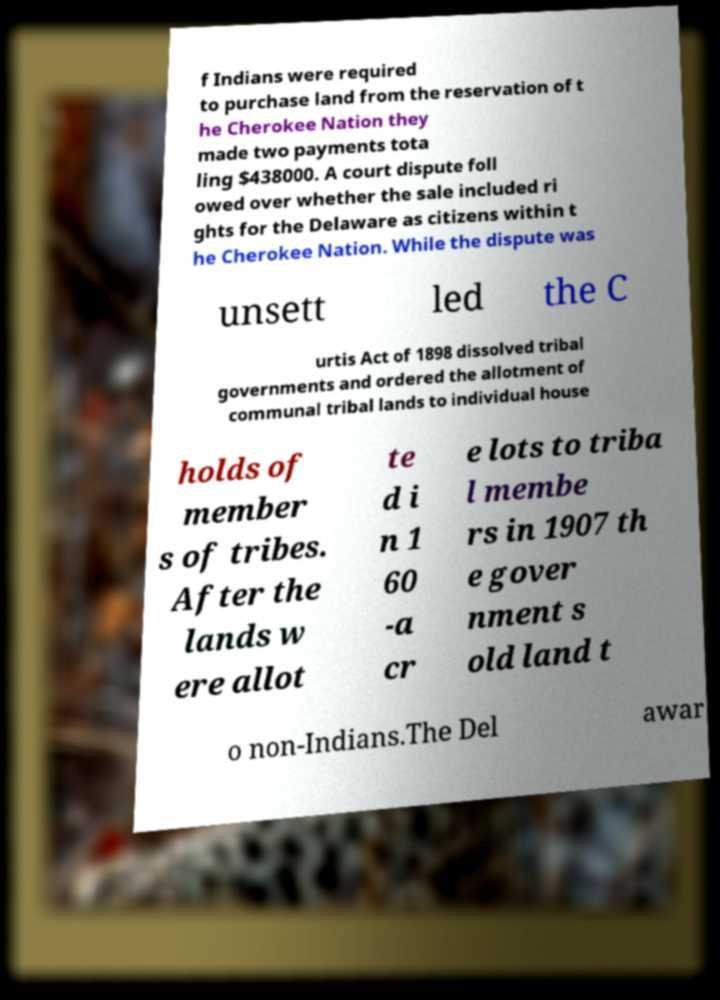There's text embedded in this image that I need extracted. Can you transcribe it verbatim? f Indians were required to purchase land from the reservation of t he Cherokee Nation they made two payments tota ling $438000. A court dispute foll owed over whether the sale included ri ghts for the Delaware as citizens within t he Cherokee Nation. While the dispute was unsett led the C urtis Act of 1898 dissolved tribal governments and ordered the allotment of communal tribal lands to individual house holds of member s of tribes. After the lands w ere allot te d i n 1 60 -a cr e lots to triba l membe rs in 1907 th e gover nment s old land t o non-Indians.The Del awar 